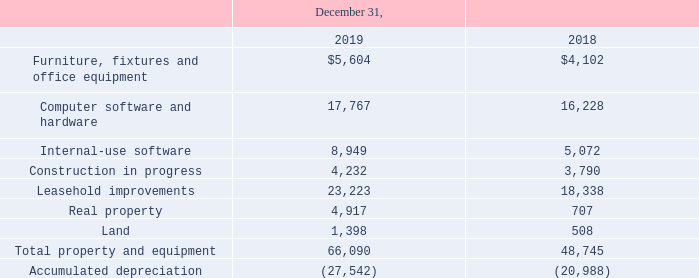Note 6. Property and Equipment, Net
Furniture and fixtures, computer software and equipment, leasehold improvements and real property are recorded at cost and presented net of depreciation. We record land at historical cost. During the application development phase, we record capitalized development costs in our construction in progress account and then reclass the asset to internal-use software when the project is ready for its intended use, which is usually when the code goes into production. Furniture, fixtures and office equipment and computer software and hardware are depreciated on a straight-line basis over lives ranging from three to five years. Internal-use software is amortized on a straight-line basis over a three-year period. Leasehold improvements are amortized on a straight-line basis over the shorter of the lease terms or the asset lives. Real property is amortized on a straightline basis over lives ranging from 15 to 39 years.
The components of property and equipment, net are as follows (in thousands):
Depreciation expense related to property and equipment for the years ended December 31, 2019, 2018 and 2017 was $5.9 million, $5.7 million and $5.4 million, respectively. Amortization expense related to internal-use software of $1.9 million, $0.8 million and $0.4 million was included in those expenses for the years ended December 31, 2019, 2018 and 2017, respectively. We had no disposals and write-offs of property and equipment that impacted the consolidated statements of operations during the year ended December 31, 2019. Within the Alarm.com segment, we disposed of and wrote off $1.4 million and $0.8 million of capitalized costs to research and development expenses within the consolidated statements of operations primarily related to the design of internal-use software that no longer met the requirements for capitalization during the years ended December 31, 2018 and 2017, respectively. In December 2019, we purchased land and a commercial building located in Liberty Lake, Washington for $5.1 million. Once renovations are complete, this building will be used by OpenEye for sales and training, research and development, warehousing and administrative purposes.
What was the depreciation expense related to property and equipment for the years ended December 31, 2019?
Answer scale should be: million. $5.9 million. How much did the company purchase land a commercial building located in Liberty Lake, Washington for in December 2019?
Answer scale should be: million. $5.1 million. What was the amount of Furniture, fixtures and office equipment in 2019?
Answer scale should be: thousand. $5,604. How many net components of property and equipment in 2019 exceeded $20,000 thousand? Leasehold improvements
Answer: 1. What was the change in leasehold improvements between 2018 and 2019?
Answer scale should be: thousand. 23,223-18,338
Answer: 4885. What was the percentage change in the total property and equipment between 2018 and 2019?
Answer scale should be: percent. (66,090-48,745)/48,745
Answer: 35.58. 